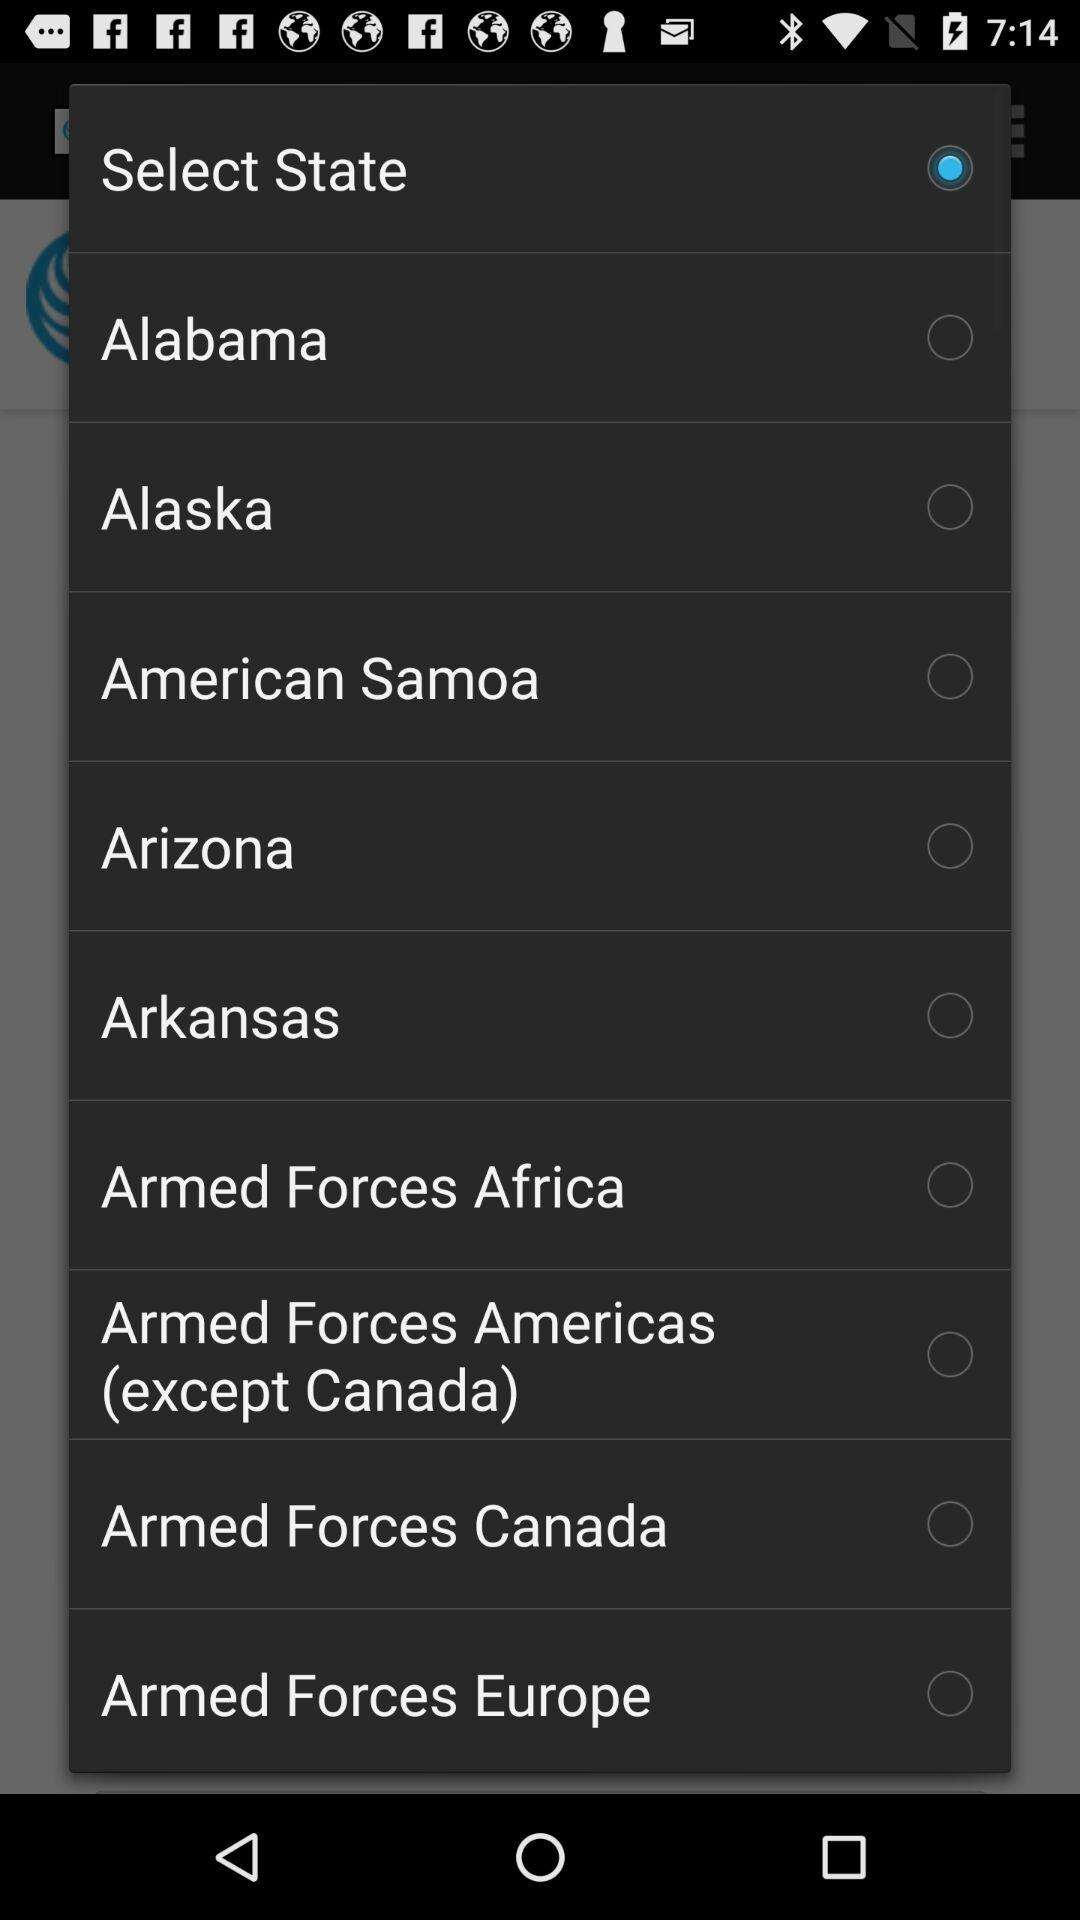Which option is selected? The selected option is "Select State". 